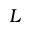<formula> <loc_0><loc_0><loc_500><loc_500>L</formula> 